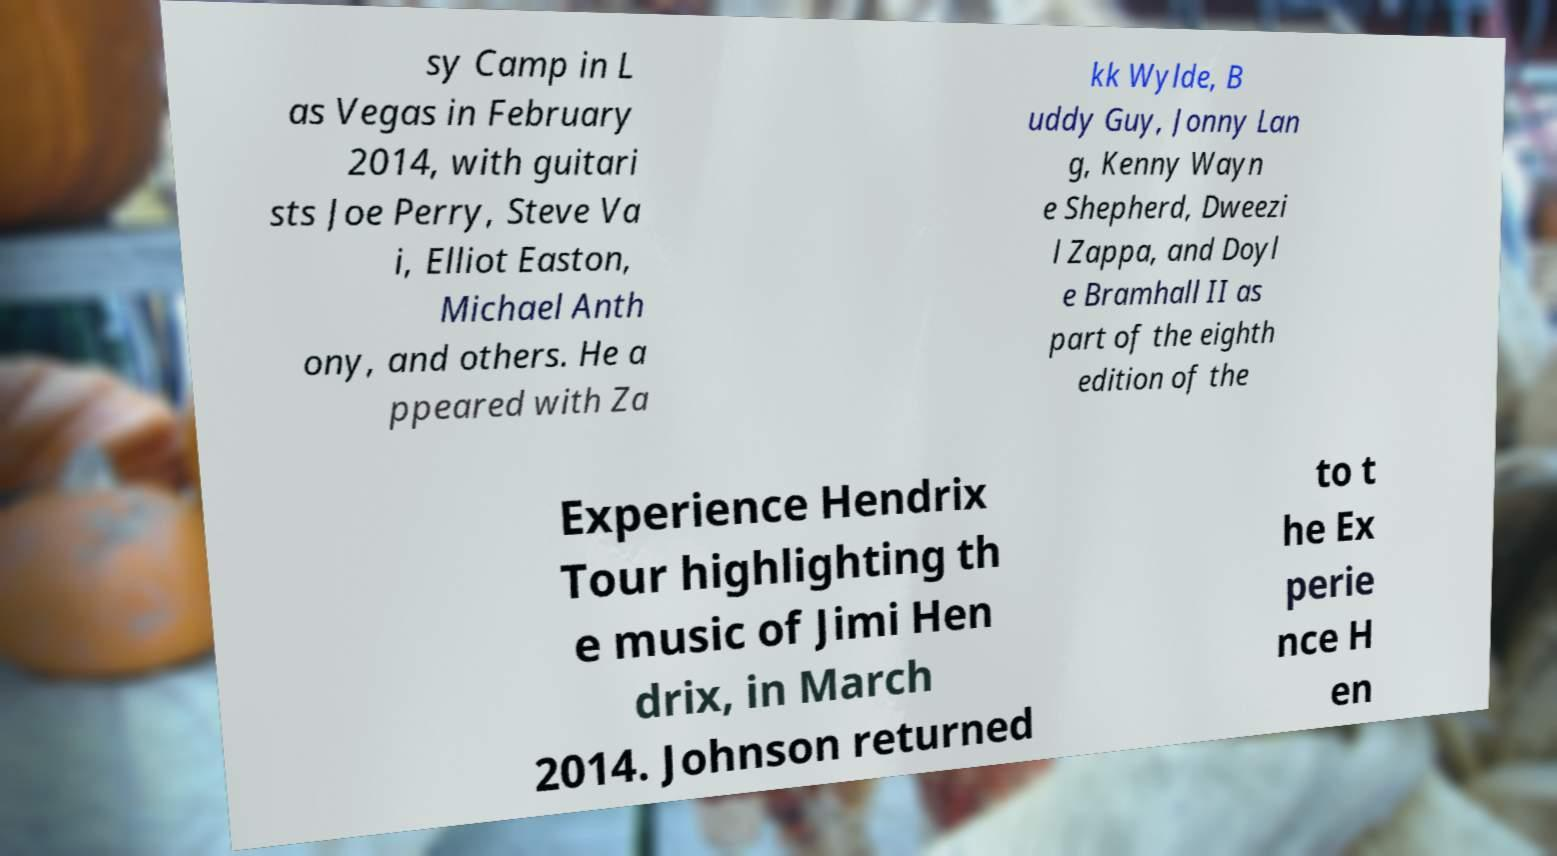Could you assist in decoding the text presented in this image and type it out clearly? sy Camp in L as Vegas in February 2014, with guitari sts Joe Perry, Steve Va i, Elliot Easton, Michael Anth ony, and others. He a ppeared with Za kk Wylde, B uddy Guy, Jonny Lan g, Kenny Wayn e Shepherd, Dweezi l Zappa, and Doyl e Bramhall II as part of the eighth edition of the Experience Hendrix Tour highlighting th e music of Jimi Hen drix, in March 2014. Johnson returned to t he Ex perie nce H en 